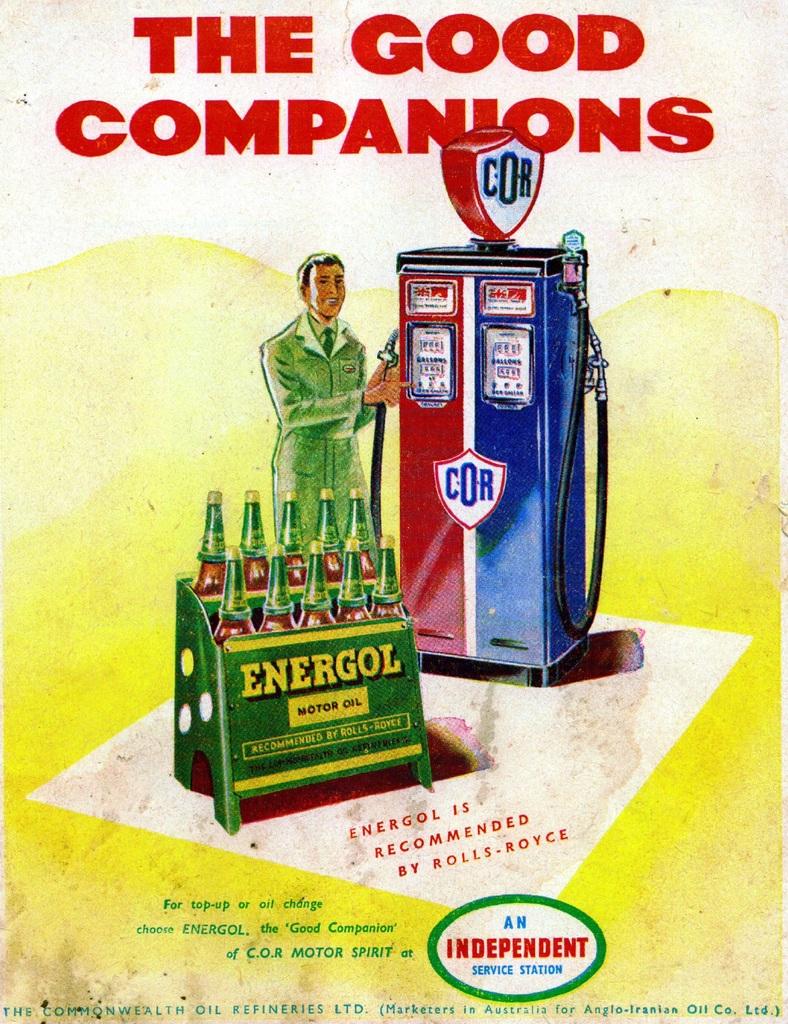What brand oil is shown?
Offer a very short reply. Energol. What's the slogan?
Give a very brief answer. The good companions. 